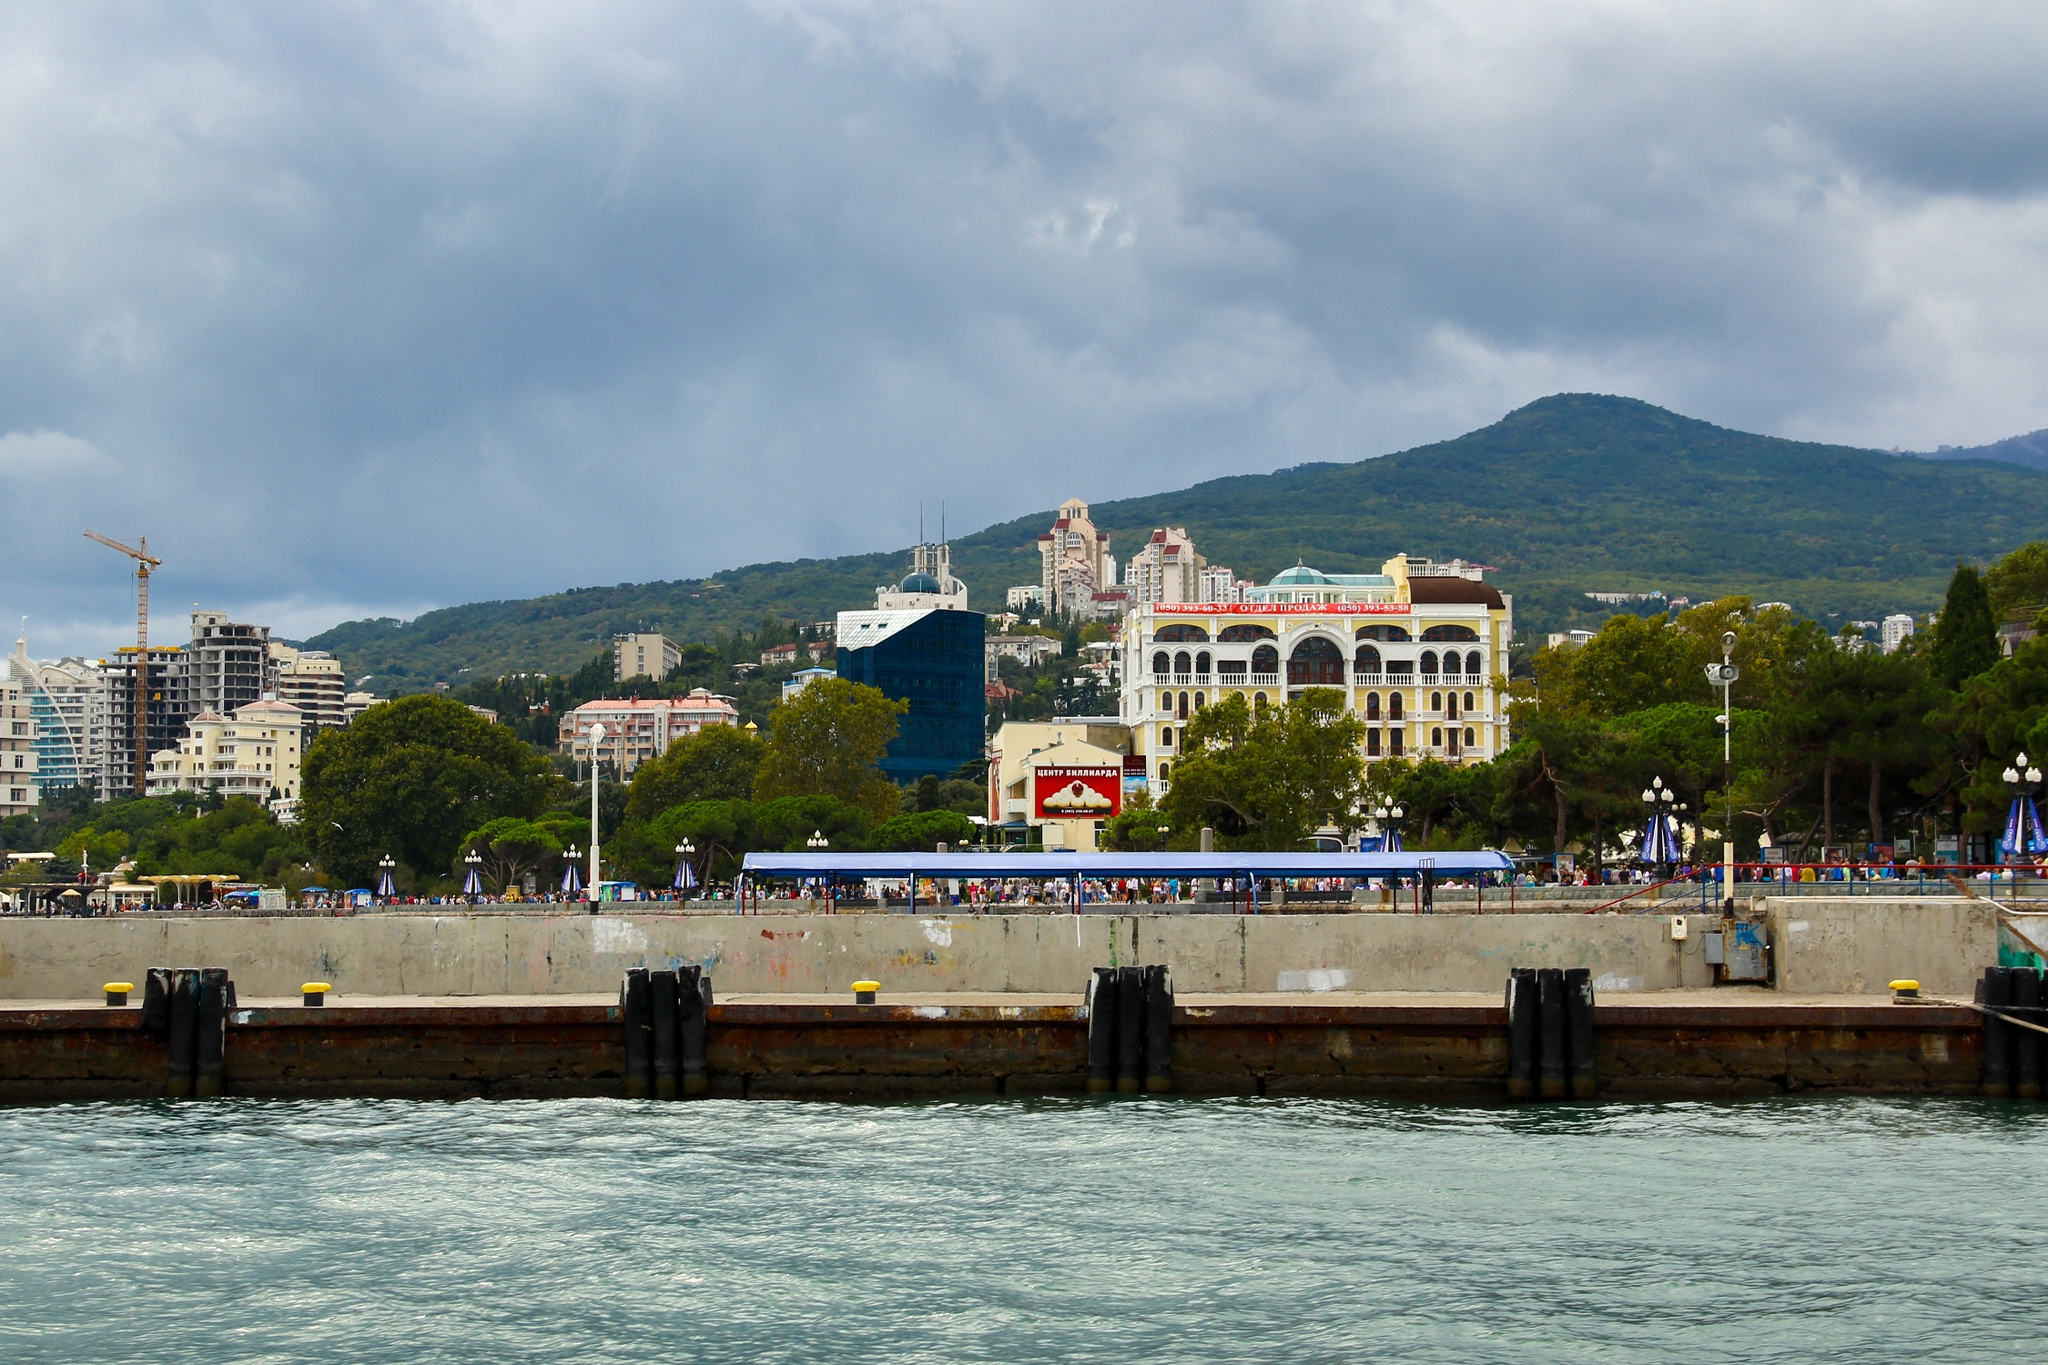What might be the seasonal changes to this scene in both a long and short response? In the summer, the Yalta seafront is a hive of activity. The pier is packed with tourists and locals alike, basking in the warm sun and enjoying various outdoor activities. The greenery is lush, and the water sparkles under the bright sunlight. Street vendors sell ice cream and cold drinks, and the smell of fresh seafood from nearby restaurants fills the air. As autumn approaches, the crowd thins, and the atmosphere becomes calmer. The leaves on the surrounding trees turn brilliant shades of red and orange, providing a stark contrast to the blue sea and buildings. A gentle breeze carries the crisp scent of the sea, and the sky often paints itself in dramatic hues as the sun sets earlier. Winters are quite different; the seafront becomes quiet and serene, with fewer visitors. The buildings, now frosted with a light dusting of snow, seem to take on a different character, standing tall against the backdrop of the evergreens. The pier, usually teeming with life, is tranquil, offering a peaceful retreat for those who enjoy the chilly yet invigorating coastal air. In summer, the seafront buzzes with activity under the warm sun. In winter, a tranquil, snowy backdrop replaces the lively scene. 